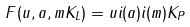<formula> <loc_0><loc_0><loc_500><loc_500>F ( u , a , m K _ { L } ) = u i ( a ) i ( m ) K _ { P }</formula> 